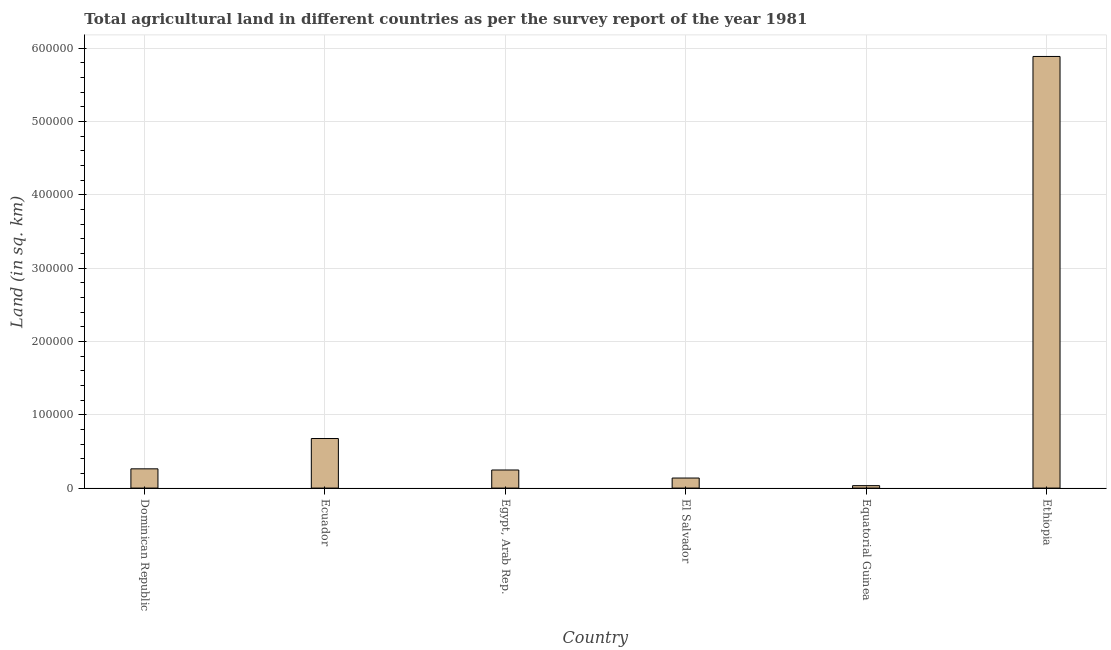Does the graph contain any zero values?
Give a very brief answer. No. Does the graph contain grids?
Ensure brevity in your answer.  Yes. What is the title of the graph?
Give a very brief answer. Total agricultural land in different countries as per the survey report of the year 1981. What is the label or title of the Y-axis?
Your response must be concise. Land (in sq. km). What is the agricultural land in Egypt, Arab Rep.?
Make the answer very short. 2.47e+04. Across all countries, what is the maximum agricultural land?
Offer a terse response. 5.89e+05. Across all countries, what is the minimum agricultural land?
Your answer should be compact. 3340. In which country was the agricultural land maximum?
Keep it short and to the point. Ethiopia. In which country was the agricultural land minimum?
Make the answer very short. Equatorial Guinea. What is the sum of the agricultural land?
Provide a short and direct response. 7.24e+05. What is the difference between the agricultural land in Egypt, Arab Rep. and Equatorial Guinea?
Offer a terse response. 2.13e+04. What is the average agricultural land per country?
Keep it short and to the point. 1.21e+05. What is the median agricultural land?
Offer a very short reply. 2.55e+04. What is the ratio of the agricultural land in Dominican Republic to that in Ethiopia?
Ensure brevity in your answer.  0.04. Is the agricultural land in Ecuador less than that in Egypt, Arab Rep.?
Give a very brief answer. No. Is the difference between the agricultural land in Dominican Republic and El Salvador greater than the difference between any two countries?
Your response must be concise. No. What is the difference between the highest and the second highest agricultural land?
Offer a terse response. 5.21e+05. Is the sum of the agricultural land in Dominican Republic and Ecuador greater than the maximum agricultural land across all countries?
Keep it short and to the point. No. What is the difference between the highest and the lowest agricultural land?
Offer a terse response. 5.85e+05. How many bars are there?
Keep it short and to the point. 6. What is the difference between two consecutive major ticks on the Y-axis?
Your response must be concise. 1.00e+05. What is the Land (in sq. km) of Dominican Republic?
Your response must be concise. 2.62e+04. What is the Land (in sq. km) of Ecuador?
Make the answer very short. 6.76e+04. What is the Land (in sq. km) of Egypt, Arab Rep.?
Your answer should be compact. 2.47e+04. What is the Land (in sq. km) in El Salvador?
Give a very brief answer. 1.37e+04. What is the Land (in sq. km) of Equatorial Guinea?
Provide a short and direct response. 3340. What is the Land (in sq. km) of Ethiopia?
Ensure brevity in your answer.  5.89e+05. What is the difference between the Land (in sq. km) in Dominican Republic and Ecuador?
Your answer should be compact. -4.13e+04. What is the difference between the Land (in sq. km) in Dominican Republic and Egypt, Arab Rep.?
Make the answer very short. 1570. What is the difference between the Land (in sq. km) in Dominican Republic and El Salvador?
Ensure brevity in your answer.  1.26e+04. What is the difference between the Land (in sq. km) in Dominican Republic and Equatorial Guinea?
Keep it short and to the point. 2.29e+04. What is the difference between the Land (in sq. km) in Dominican Republic and Ethiopia?
Ensure brevity in your answer.  -5.62e+05. What is the difference between the Land (in sq. km) in Ecuador and Egypt, Arab Rep.?
Provide a succinct answer. 4.29e+04. What is the difference between the Land (in sq. km) in Ecuador and El Salvador?
Make the answer very short. 5.39e+04. What is the difference between the Land (in sq. km) in Ecuador and Equatorial Guinea?
Provide a short and direct response. 6.42e+04. What is the difference between the Land (in sq. km) in Ecuador and Ethiopia?
Your answer should be very brief. -5.21e+05. What is the difference between the Land (in sq. km) in Egypt, Arab Rep. and El Salvador?
Your answer should be compact. 1.10e+04. What is the difference between the Land (in sq. km) in Egypt, Arab Rep. and Equatorial Guinea?
Offer a very short reply. 2.13e+04. What is the difference between the Land (in sq. km) in Egypt, Arab Rep. and Ethiopia?
Offer a terse response. -5.64e+05. What is the difference between the Land (in sq. km) in El Salvador and Equatorial Guinea?
Offer a very short reply. 1.04e+04. What is the difference between the Land (in sq. km) in El Salvador and Ethiopia?
Give a very brief answer. -5.75e+05. What is the difference between the Land (in sq. km) in Equatorial Guinea and Ethiopia?
Make the answer very short. -5.85e+05. What is the ratio of the Land (in sq. km) in Dominican Republic to that in Ecuador?
Your response must be concise. 0.39. What is the ratio of the Land (in sq. km) in Dominican Republic to that in Egypt, Arab Rep.?
Offer a very short reply. 1.06. What is the ratio of the Land (in sq. km) in Dominican Republic to that in El Salvador?
Offer a very short reply. 1.92. What is the ratio of the Land (in sq. km) in Dominican Republic to that in Equatorial Guinea?
Provide a short and direct response. 7.86. What is the ratio of the Land (in sq. km) in Dominican Republic to that in Ethiopia?
Offer a terse response. 0.04. What is the ratio of the Land (in sq. km) in Ecuador to that in Egypt, Arab Rep.?
Keep it short and to the point. 2.74. What is the ratio of the Land (in sq. km) in Ecuador to that in El Salvador?
Give a very brief answer. 4.93. What is the ratio of the Land (in sq. km) in Ecuador to that in Equatorial Guinea?
Provide a succinct answer. 20.24. What is the ratio of the Land (in sq. km) in Ecuador to that in Ethiopia?
Your answer should be very brief. 0.12. What is the ratio of the Land (in sq. km) in Egypt, Arab Rep. to that in El Salvador?
Offer a terse response. 1.8. What is the ratio of the Land (in sq. km) in Egypt, Arab Rep. to that in Equatorial Guinea?
Provide a succinct answer. 7.39. What is the ratio of the Land (in sq. km) in Egypt, Arab Rep. to that in Ethiopia?
Make the answer very short. 0.04. What is the ratio of the Land (in sq. km) in El Salvador to that in Equatorial Guinea?
Offer a very short reply. 4.1. What is the ratio of the Land (in sq. km) in El Salvador to that in Ethiopia?
Give a very brief answer. 0.02. What is the ratio of the Land (in sq. km) in Equatorial Guinea to that in Ethiopia?
Your response must be concise. 0.01. 